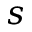<formula> <loc_0><loc_0><loc_500><loc_500>s</formula> 